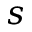<formula> <loc_0><loc_0><loc_500><loc_500>s</formula> 